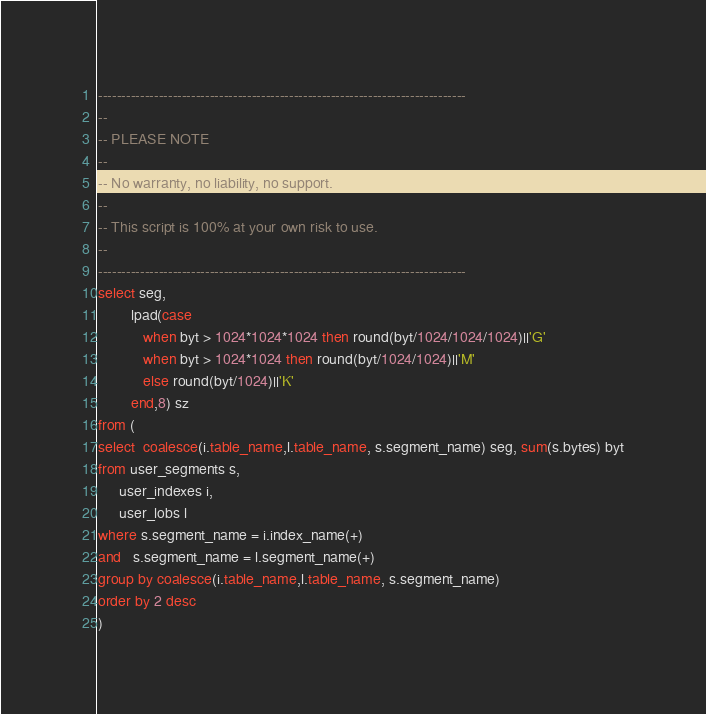Convert code to text. <code><loc_0><loc_0><loc_500><loc_500><_SQL_>-------------------------------------------------------------------------------
--
-- PLEASE NOTE
-- 
-- No warranty, no liability, no support.
--
-- This script is 100% at your own risk to use.
--
-------------------------------------------------------------------------------
select seg, 
        lpad(case 
           when byt > 1024*1024*1024 then round(byt/1024/1024/1024)||'G'
           when byt > 1024*1024 then round(byt/1024/1024)||'M'
           else round(byt/1024)||'K'
        end,8) sz
from (        
select  coalesce(i.table_name,l.table_name, s.segment_name) seg, sum(s.bytes) byt
from user_segments s,
     user_indexes i,
     user_lobs l
where s.segment_name = i.index_name(+)
and   s.segment_name = l.segment_name(+)     
group by coalesce(i.table_name,l.table_name, s.segment_name)
order by 2 desc
)


</code> 